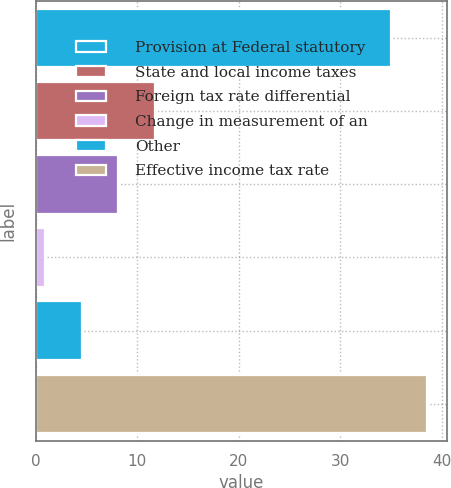Convert chart to OTSL. <chart><loc_0><loc_0><loc_500><loc_500><bar_chart><fcel>Provision at Federal statutory<fcel>State and local income taxes<fcel>Foreign tax rate differential<fcel>Change in measurement of an<fcel>Other<fcel>Effective income tax rate<nl><fcel>35<fcel>11.73<fcel>8.12<fcel>0.9<fcel>4.51<fcel>38.61<nl></chart> 